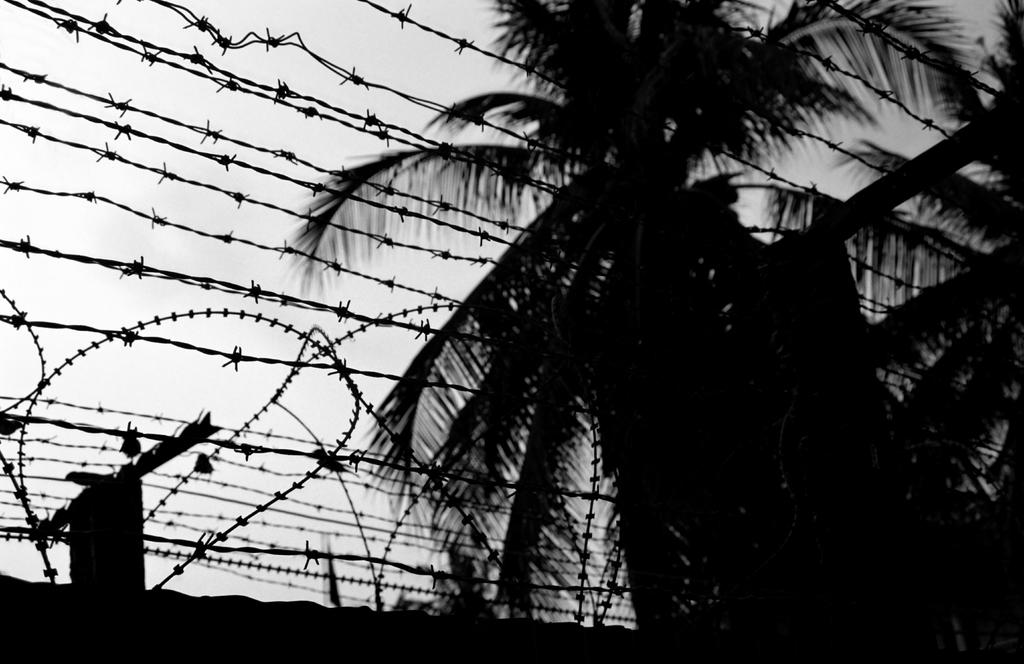What type of barrier is present in the image? There is a wall with a fence wire in the image. What is special about the fence wire? The fence wire has an electric mesh. What type of tree can be seen in the image? There is a coconut tree visible in the image. What part of the natural environment is visible in the image? The sky is visible in the image. Where is the plantation located in the image? There is no plantation present in the image. What type of crack is visible on the coconut tree? There is no crack visible on the coconut tree in the image. 